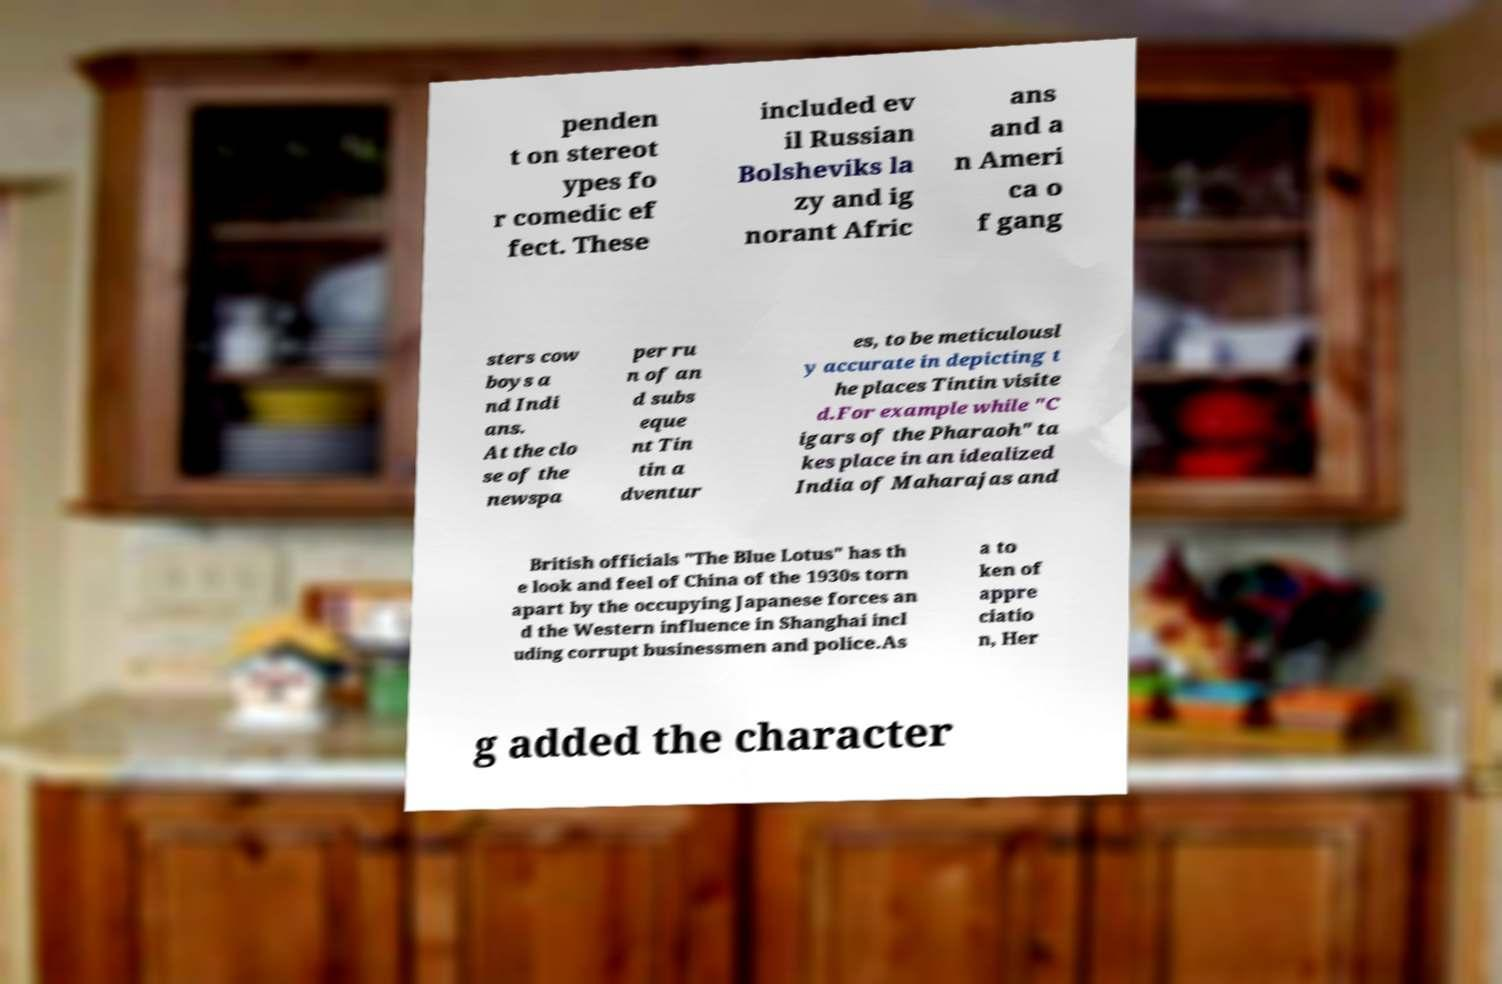Please read and relay the text visible in this image. What does it say? penden t on stereot ypes fo r comedic ef fect. These included ev il Russian Bolsheviks la zy and ig norant Afric ans and a n Ameri ca o f gang sters cow boys a nd Indi ans. At the clo se of the newspa per ru n of an d subs eque nt Tin tin a dventur es, to be meticulousl y accurate in depicting t he places Tintin visite d.For example while "C igars of the Pharaoh" ta kes place in an idealized India of Maharajas and British officials "The Blue Lotus" has th e look and feel of China of the 1930s torn apart by the occupying Japanese forces an d the Western influence in Shanghai incl uding corrupt businessmen and police.As a to ken of appre ciatio n, Her g added the character 